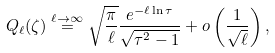<formula> <loc_0><loc_0><loc_500><loc_500>Q _ { \ell } ( \zeta ) \stackrel { \ell \to \infty } { = } \sqrt { \frac { \pi } { \ell } } \frac { e ^ { - \ell \ln { \tau } } } { \sqrt { \tau ^ { 2 } - 1 } } + o \left ( \frac { 1 } { \sqrt { \ell } } \right ) ,</formula> 